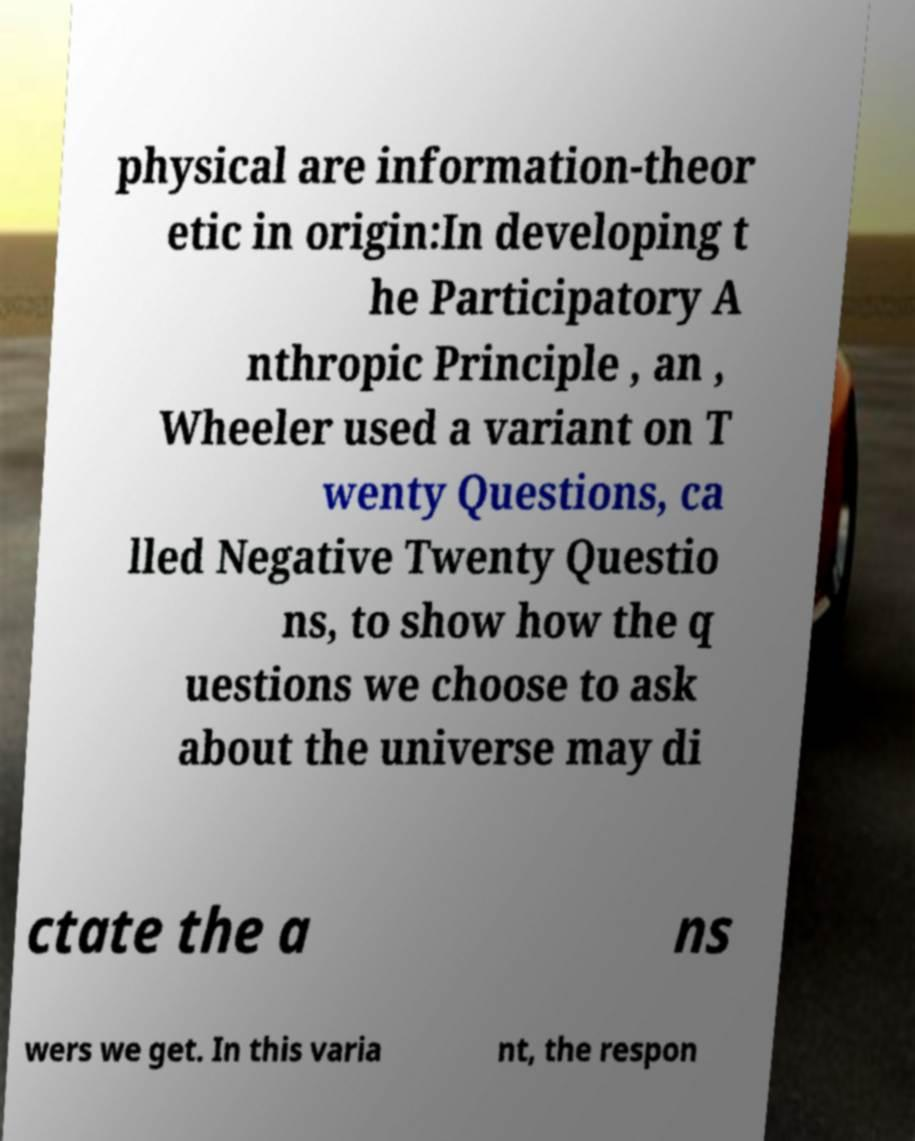Can you read and provide the text displayed in the image?This photo seems to have some interesting text. Can you extract and type it out for me? physical are information-theor etic in origin:In developing t he Participatory A nthropic Principle , an , Wheeler used a variant on T wenty Questions, ca lled Negative Twenty Questio ns, to show how the q uestions we choose to ask about the universe may di ctate the a ns wers we get. In this varia nt, the respon 